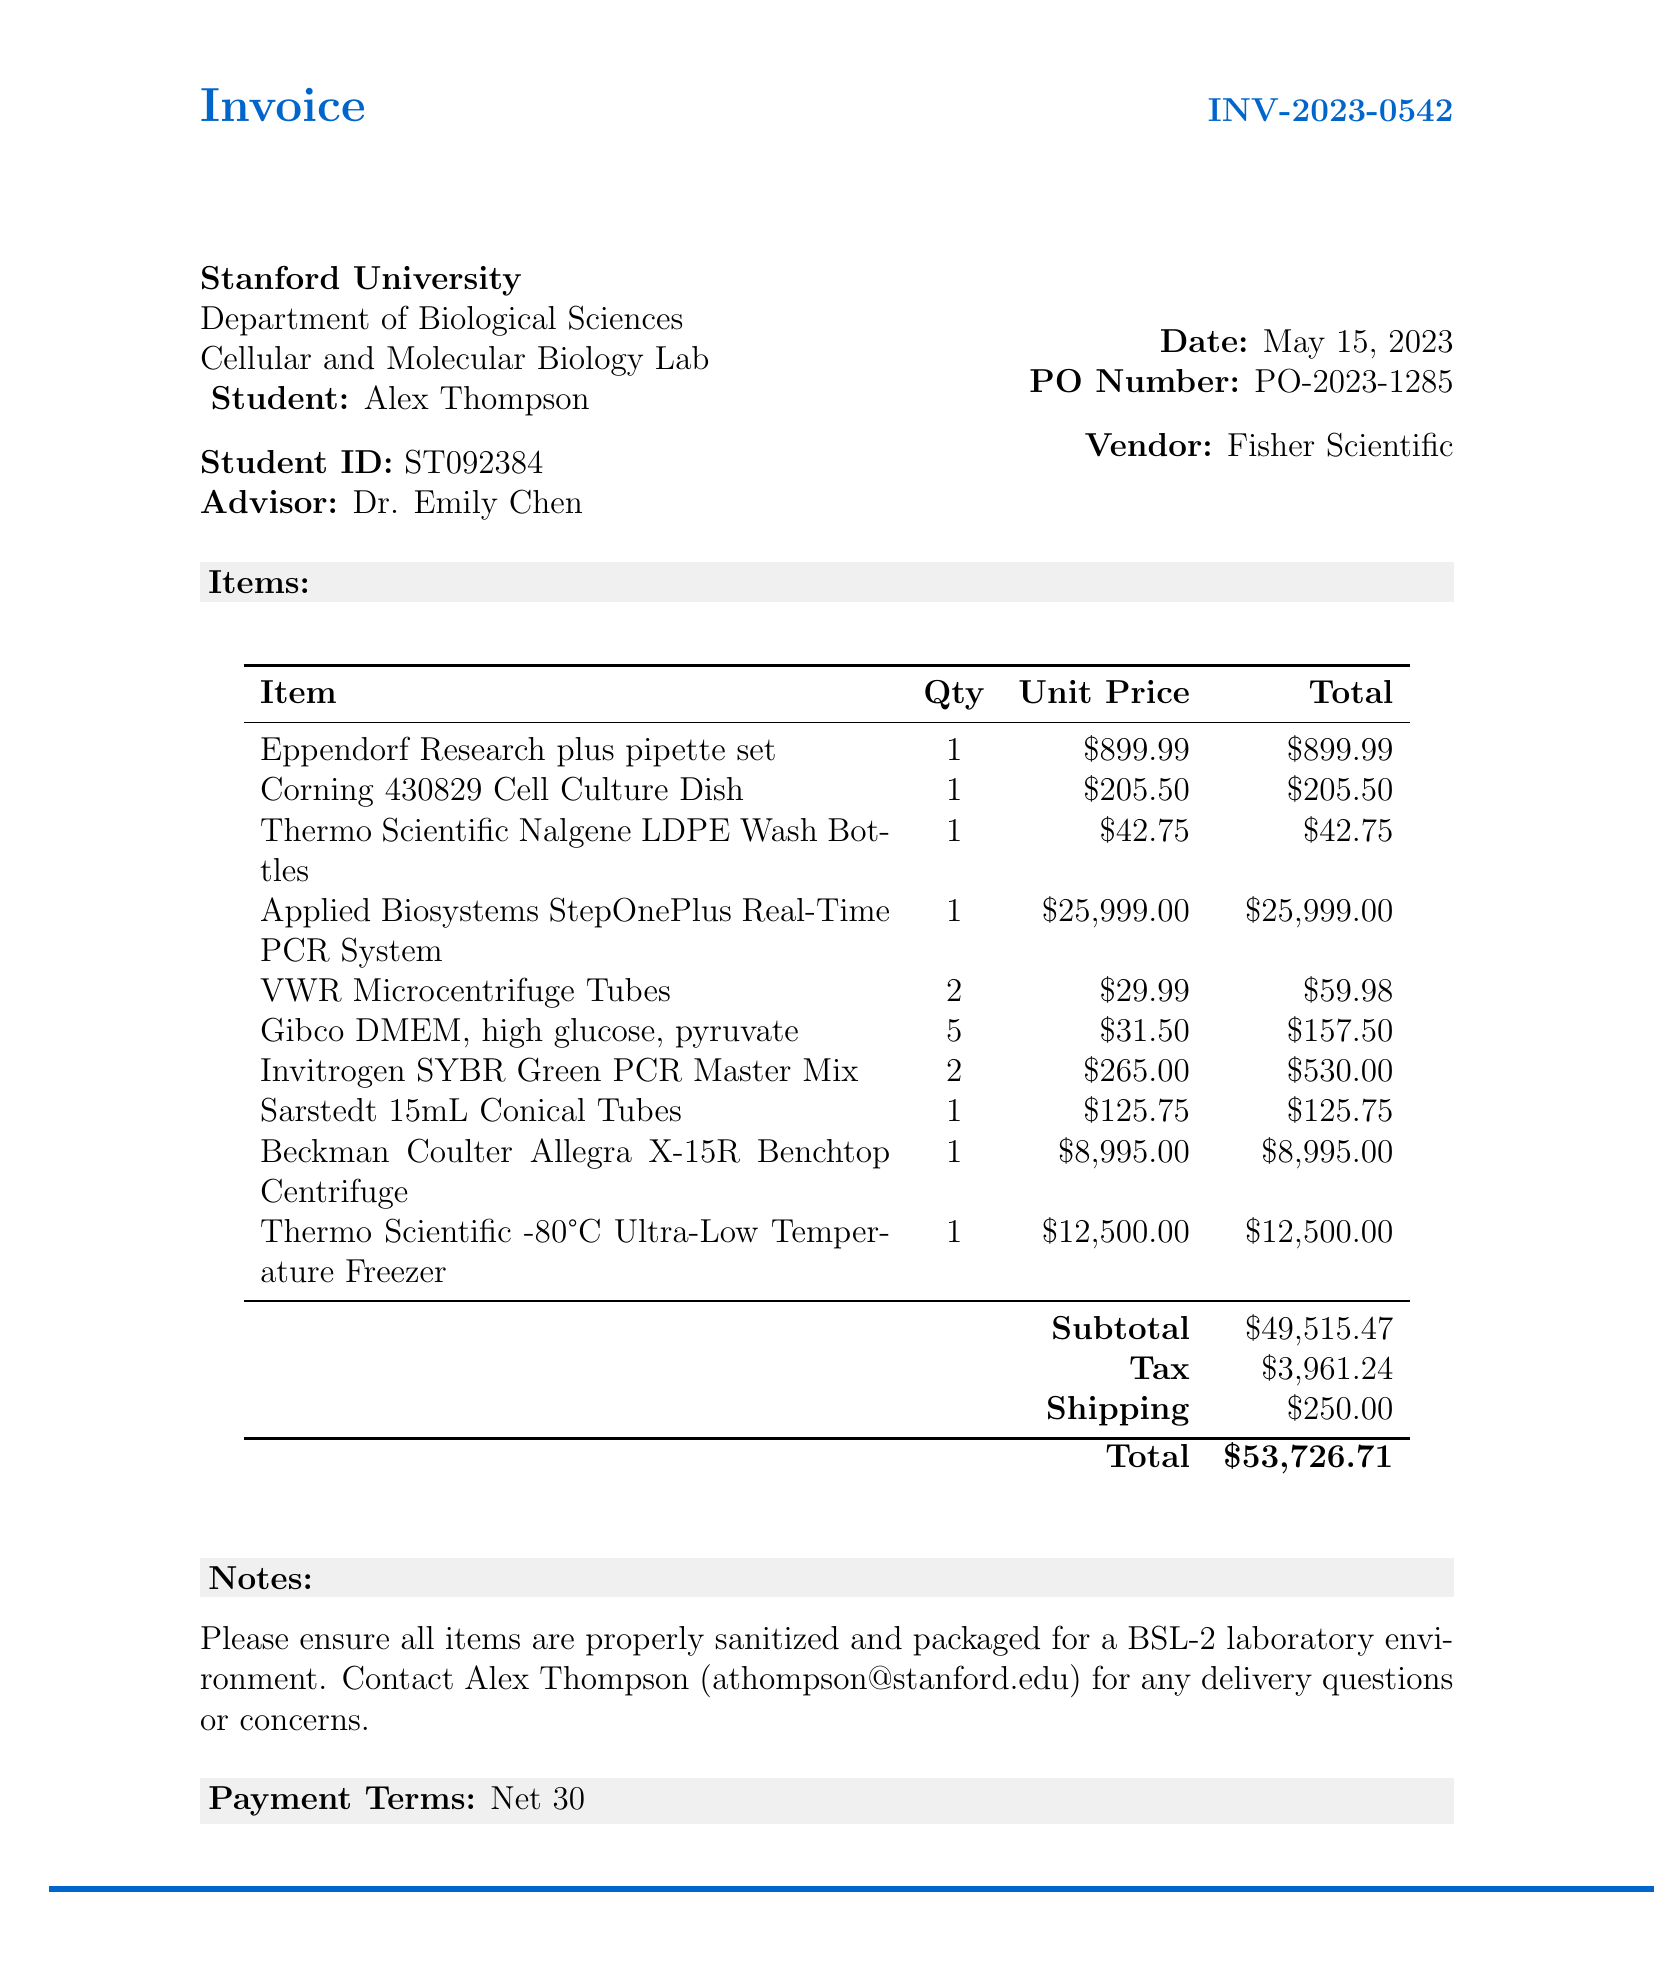What is the invoice number? The invoice number is listed at the top of the document, identifying this specific transaction.
Answer: INV-2023-0542 Who is the vendor for the research equipment? The vendor section specifies the company supplying the items, which is crucial for procurement records.
Answer: Fisher Scientific What is the total amount due? The total amount due is calculated by adding the subtotal, tax, and shipping costs.
Answer: $53,726.71 How many Eppendorf pipette sets were purchased? The itemized list shows the quantity for each item ordered, important for inventory tracking.
Answer: 1 What is the purchase order number? The purchase order number helps in managing financial documents and tracking orders easily.
Answer: PO-2023-1285 What is the tax amount on this invoice? The tax amount is a key financial figure necessary for budget accounting and compliance.
Answer: $3,961.24 How many types of items are listed in the invoice? The number of items indicates the range of supplies acquired and helps summarize purchases.
Answer: 10 What specific instructions were provided regarding item packaging? The instructions ensure compliance with laboratory safety and sanitation standards during delivery.
Answer: Properly sanitized and packaged for a BSL-2 laboratory environment 